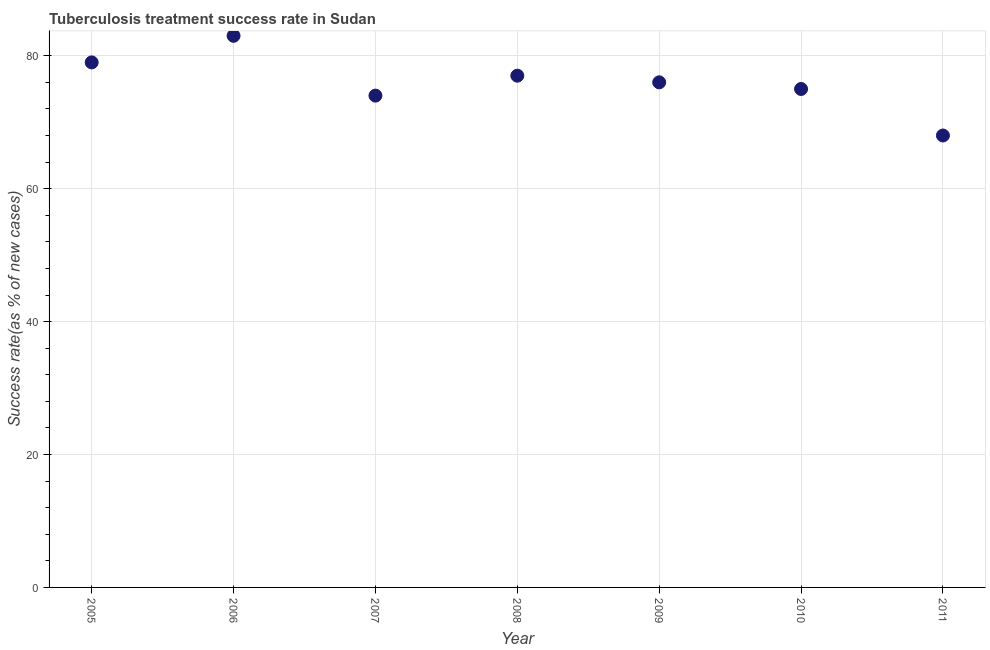What is the tuberculosis treatment success rate in 2011?
Offer a very short reply. 68. Across all years, what is the maximum tuberculosis treatment success rate?
Your answer should be very brief. 83. Across all years, what is the minimum tuberculosis treatment success rate?
Offer a terse response. 68. What is the sum of the tuberculosis treatment success rate?
Your response must be concise. 532. What is the difference between the tuberculosis treatment success rate in 2006 and 2007?
Your answer should be compact. 9. Do a majority of the years between 2007 and 2010 (inclusive) have tuberculosis treatment success rate greater than 12 %?
Make the answer very short. Yes. What is the ratio of the tuberculosis treatment success rate in 2010 to that in 2011?
Your response must be concise. 1.1. Is the difference between the tuberculosis treatment success rate in 2006 and 2008 greater than the difference between any two years?
Keep it short and to the point. No. What is the difference between the highest and the lowest tuberculosis treatment success rate?
Ensure brevity in your answer.  15. Does the tuberculosis treatment success rate monotonically increase over the years?
Your answer should be very brief. No. How many dotlines are there?
Your response must be concise. 1. What is the difference between two consecutive major ticks on the Y-axis?
Provide a succinct answer. 20. Does the graph contain any zero values?
Ensure brevity in your answer.  No. Does the graph contain grids?
Ensure brevity in your answer.  Yes. What is the title of the graph?
Keep it short and to the point. Tuberculosis treatment success rate in Sudan. What is the label or title of the X-axis?
Provide a short and direct response. Year. What is the label or title of the Y-axis?
Your answer should be very brief. Success rate(as % of new cases). What is the Success rate(as % of new cases) in 2005?
Your response must be concise. 79. What is the Success rate(as % of new cases) in 2010?
Your answer should be compact. 75. What is the Success rate(as % of new cases) in 2011?
Your answer should be very brief. 68. What is the difference between the Success rate(as % of new cases) in 2005 and 2006?
Provide a short and direct response. -4. What is the difference between the Success rate(as % of new cases) in 2005 and 2007?
Ensure brevity in your answer.  5. What is the difference between the Success rate(as % of new cases) in 2005 and 2011?
Your response must be concise. 11. What is the difference between the Success rate(as % of new cases) in 2006 and 2007?
Your answer should be compact. 9. What is the difference between the Success rate(as % of new cases) in 2006 and 2008?
Offer a very short reply. 6. What is the difference between the Success rate(as % of new cases) in 2006 and 2009?
Offer a terse response. 7. What is the difference between the Success rate(as % of new cases) in 2006 and 2010?
Your answer should be very brief. 8. What is the difference between the Success rate(as % of new cases) in 2006 and 2011?
Ensure brevity in your answer.  15. What is the difference between the Success rate(as % of new cases) in 2007 and 2008?
Give a very brief answer. -3. What is the difference between the Success rate(as % of new cases) in 2008 and 2011?
Offer a terse response. 9. What is the difference between the Success rate(as % of new cases) in 2009 and 2010?
Offer a very short reply. 1. What is the difference between the Success rate(as % of new cases) in 2009 and 2011?
Give a very brief answer. 8. What is the ratio of the Success rate(as % of new cases) in 2005 to that in 2007?
Make the answer very short. 1.07. What is the ratio of the Success rate(as % of new cases) in 2005 to that in 2008?
Your response must be concise. 1.03. What is the ratio of the Success rate(as % of new cases) in 2005 to that in 2009?
Your response must be concise. 1.04. What is the ratio of the Success rate(as % of new cases) in 2005 to that in 2010?
Your answer should be very brief. 1.05. What is the ratio of the Success rate(as % of new cases) in 2005 to that in 2011?
Give a very brief answer. 1.16. What is the ratio of the Success rate(as % of new cases) in 2006 to that in 2007?
Offer a terse response. 1.12. What is the ratio of the Success rate(as % of new cases) in 2006 to that in 2008?
Provide a succinct answer. 1.08. What is the ratio of the Success rate(as % of new cases) in 2006 to that in 2009?
Provide a succinct answer. 1.09. What is the ratio of the Success rate(as % of new cases) in 2006 to that in 2010?
Ensure brevity in your answer.  1.11. What is the ratio of the Success rate(as % of new cases) in 2006 to that in 2011?
Provide a succinct answer. 1.22. What is the ratio of the Success rate(as % of new cases) in 2007 to that in 2008?
Ensure brevity in your answer.  0.96. What is the ratio of the Success rate(as % of new cases) in 2007 to that in 2011?
Provide a short and direct response. 1.09. What is the ratio of the Success rate(as % of new cases) in 2008 to that in 2010?
Provide a short and direct response. 1.03. What is the ratio of the Success rate(as % of new cases) in 2008 to that in 2011?
Offer a very short reply. 1.13. What is the ratio of the Success rate(as % of new cases) in 2009 to that in 2011?
Offer a very short reply. 1.12. What is the ratio of the Success rate(as % of new cases) in 2010 to that in 2011?
Make the answer very short. 1.1. 